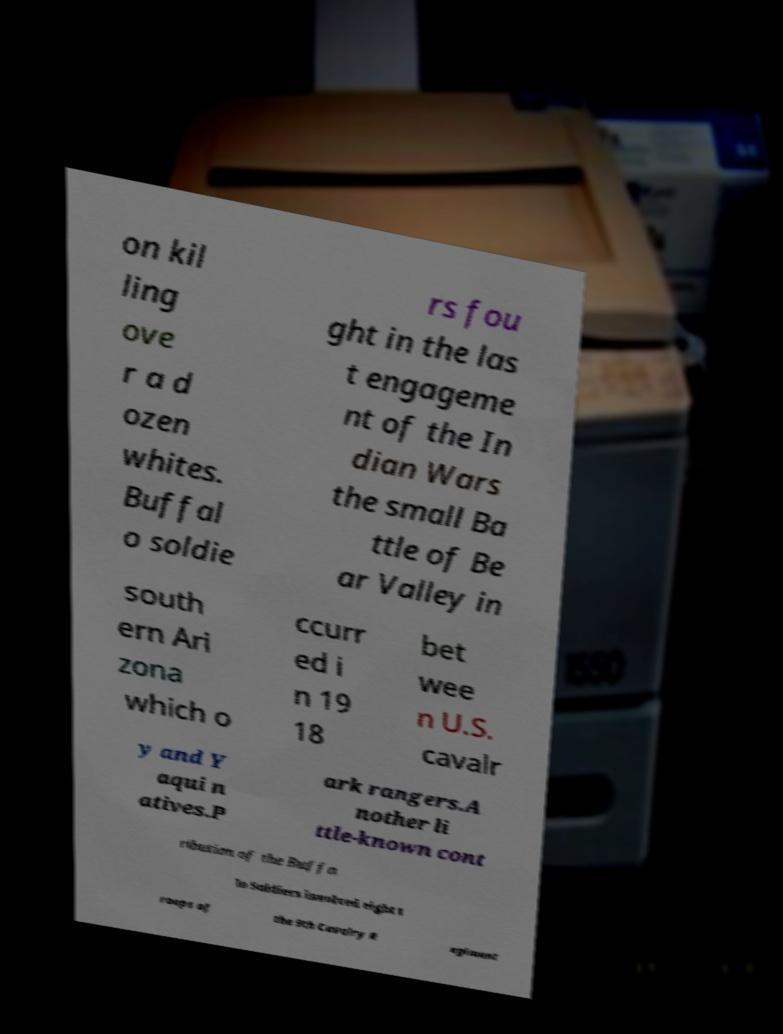I need the written content from this picture converted into text. Can you do that? on kil ling ove r a d ozen whites. Buffal o soldie rs fou ght in the las t engageme nt of the In dian Wars the small Ba ttle of Be ar Valley in south ern Ari zona which o ccurr ed i n 19 18 bet wee n U.S. cavalr y and Y aqui n atives.P ark rangers.A nother li ttle-known cont ribution of the Buffa lo Soldiers involved eight t roops of the 9th Cavalry R egiment 